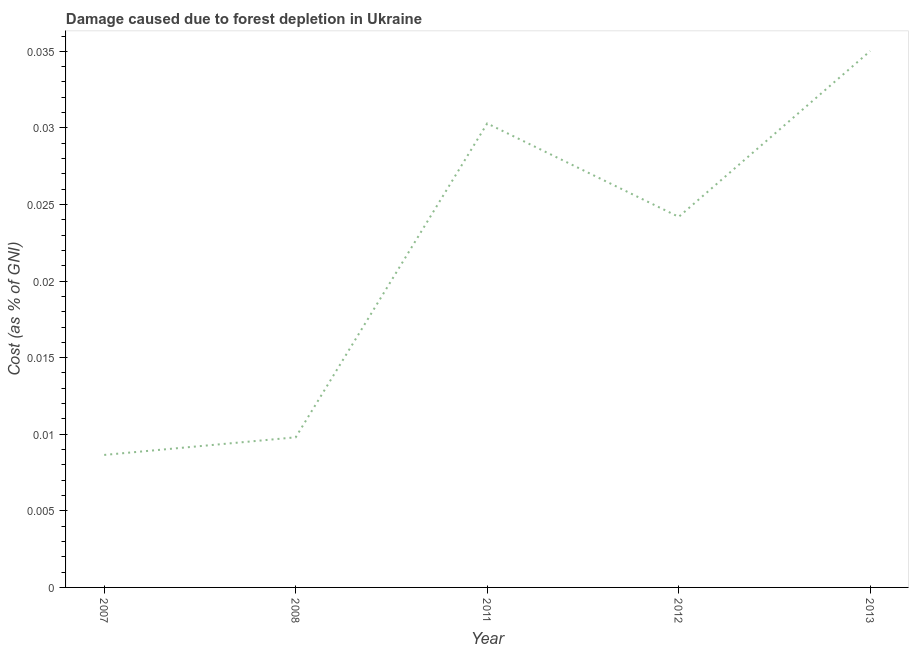What is the damage caused due to forest depletion in 2008?
Ensure brevity in your answer.  0.01. Across all years, what is the maximum damage caused due to forest depletion?
Offer a very short reply. 0.04. Across all years, what is the minimum damage caused due to forest depletion?
Ensure brevity in your answer.  0.01. In which year was the damage caused due to forest depletion maximum?
Your response must be concise. 2013. In which year was the damage caused due to forest depletion minimum?
Offer a very short reply. 2007. What is the sum of the damage caused due to forest depletion?
Your response must be concise. 0.11. What is the difference between the damage caused due to forest depletion in 2008 and 2011?
Provide a succinct answer. -0.02. What is the average damage caused due to forest depletion per year?
Offer a terse response. 0.02. What is the median damage caused due to forest depletion?
Give a very brief answer. 0.02. In how many years, is the damage caused due to forest depletion greater than 0.002 %?
Provide a succinct answer. 5. What is the ratio of the damage caused due to forest depletion in 2012 to that in 2013?
Your response must be concise. 0.69. Is the difference between the damage caused due to forest depletion in 2007 and 2013 greater than the difference between any two years?
Ensure brevity in your answer.  Yes. What is the difference between the highest and the second highest damage caused due to forest depletion?
Keep it short and to the point. 0. Is the sum of the damage caused due to forest depletion in 2007 and 2011 greater than the maximum damage caused due to forest depletion across all years?
Your answer should be compact. Yes. What is the difference between the highest and the lowest damage caused due to forest depletion?
Give a very brief answer. 0.03. In how many years, is the damage caused due to forest depletion greater than the average damage caused due to forest depletion taken over all years?
Ensure brevity in your answer.  3. How many lines are there?
Ensure brevity in your answer.  1. How many years are there in the graph?
Keep it short and to the point. 5. What is the difference between two consecutive major ticks on the Y-axis?
Provide a succinct answer. 0.01. Are the values on the major ticks of Y-axis written in scientific E-notation?
Offer a very short reply. No. Does the graph contain any zero values?
Provide a short and direct response. No. What is the title of the graph?
Provide a short and direct response. Damage caused due to forest depletion in Ukraine. What is the label or title of the X-axis?
Provide a succinct answer. Year. What is the label or title of the Y-axis?
Your answer should be very brief. Cost (as % of GNI). What is the Cost (as % of GNI) in 2007?
Your response must be concise. 0.01. What is the Cost (as % of GNI) of 2008?
Give a very brief answer. 0.01. What is the Cost (as % of GNI) of 2011?
Ensure brevity in your answer.  0.03. What is the Cost (as % of GNI) in 2012?
Offer a very short reply. 0.02. What is the Cost (as % of GNI) of 2013?
Offer a very short reply. 0.04. What is the difference between the Cost (as % of GNI) in 2007 and 2008?
Your response must be concise. -0. What is the difference between the Cost (as % of GNI) in 2007 and 2011?
Provide a short and direct response. -0.02. What is the difference between the Cost (as % of GNI) in 2007 and 2012?
Your answer should be compact. -0.02. What is the difference between the Cost (as % of GNI) in 2007 and 2013?
Offer a very short reply. -0.03. What is the difference between the Cost (as % of GNI) in 2008 and 2011?
Ensure brevity in your answer.  -0.02. What is the difference between the Cost (as % of GNI) in 2008 and 2012?
Make the answer very short. -0.01. What is the difference between the Cost (as % of GNI) in 2008 and 2013?
Provide a short and direct response. -0.03. What is the difference between the Cost (as % of GNI) in 2011 and 2012?
Provide a short and direct response. 0.01. What is the difference between the Cost (as % of GNI) in 2011 and 2013?
Provide a short and direct response. -0. What is the difference between the Cost (as % of GNI) in 2012 and 2013?
Keep it short and to the point. -0.01. What is the ratio of the Cost (as % of GNI) in 2007 to that in 2008?
Your response must be concise. 0.88. What is the ratio of the Cost (as % of GNI) in 2007 to that in 2011?
Offer a very short reply. 0.29. What is the ratio of the Cost (as % of GNI) in 2007 to that in 2012?
Ensure brevity in your answer.  0.36. What is the ratio of the Cost (as % of GNI) in 2007 to that in 2013?
Provide a short and direct response. 0.25. What is the ratio of the Cost (as % of GNI) in 2008 to that in 2011?
Offer a very short reply. 0.32. What is the ratio of the Cost (as % of GNI) in 2008 to that in 2012?
Offer a terse response. 0.41. What is the ratio of the Cost (as % of GNI) in 2008 to that in 2013?
Offer a terse response. 0.28. What is the ratio of the Cost (as % of GNI) in 2011 to that in 2012?
Offer a very short reply. 1.25. What is the ratio of the Cost (as % of GNI) in 2011 to that in 2013?
Your response must be concise. 0.86. What is the ratio of the Cost (as % of GNI) in 2012 to that in 2013?
Give a very brief answer. 0.69. 